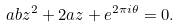Convert formula to latex. <formula><loc_0><loc_0><loc_500><loc_500>a b z ^ { 2 } + 2 a z + e ^ { 2 \pi i \theta } = 0 .</formula> 